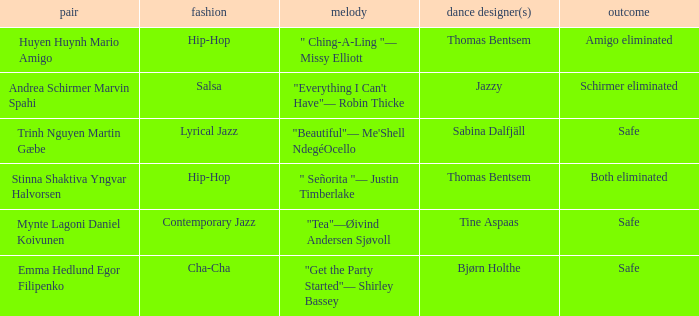What couple had a safe result and a lyrical jazz style? Trinh Nguyen Martin Gæbe. 